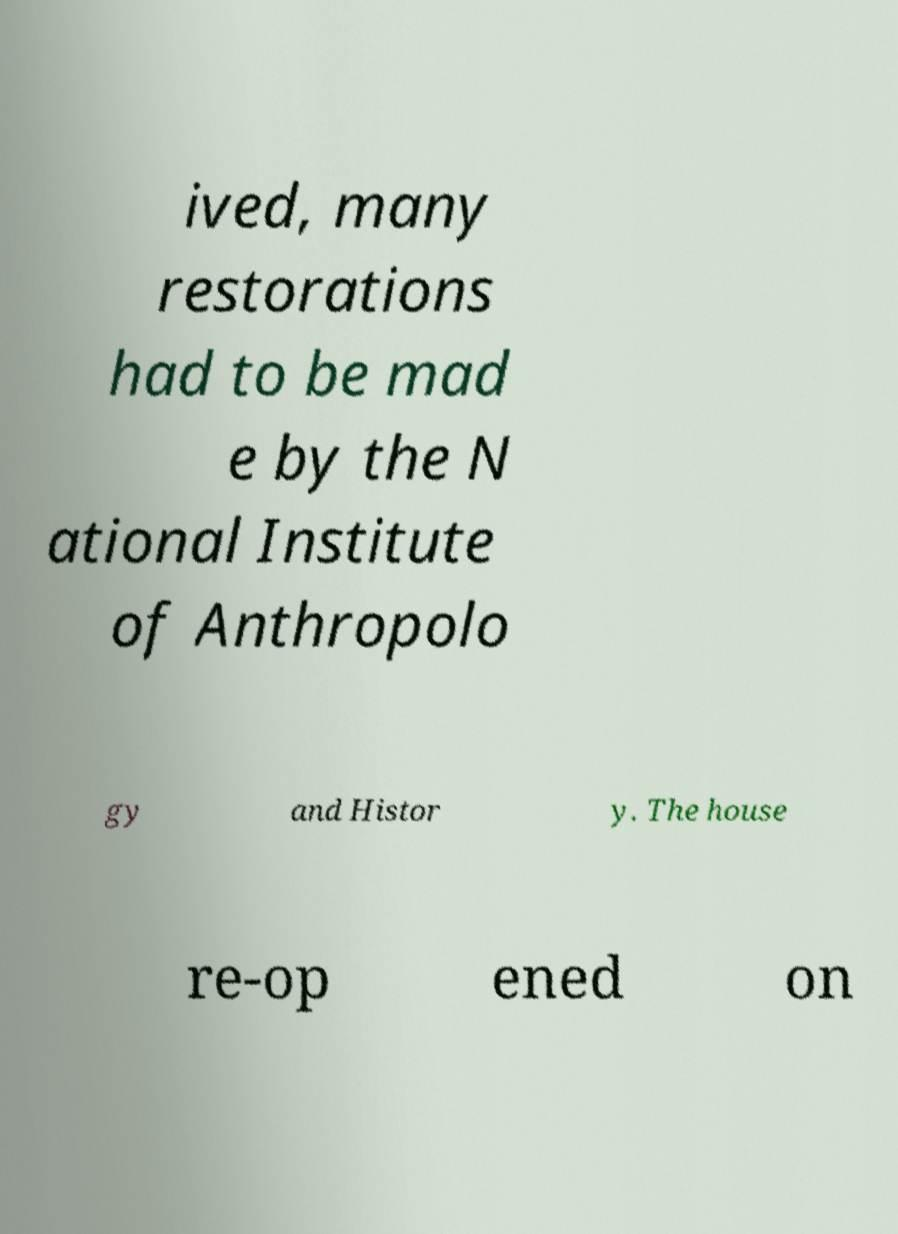I need the written content from this picture converted into text. Can you do that? ived, many restorations had to be mad e by the N ational Institute of Anthropolo gy and Histor y. The house re-op ened on 